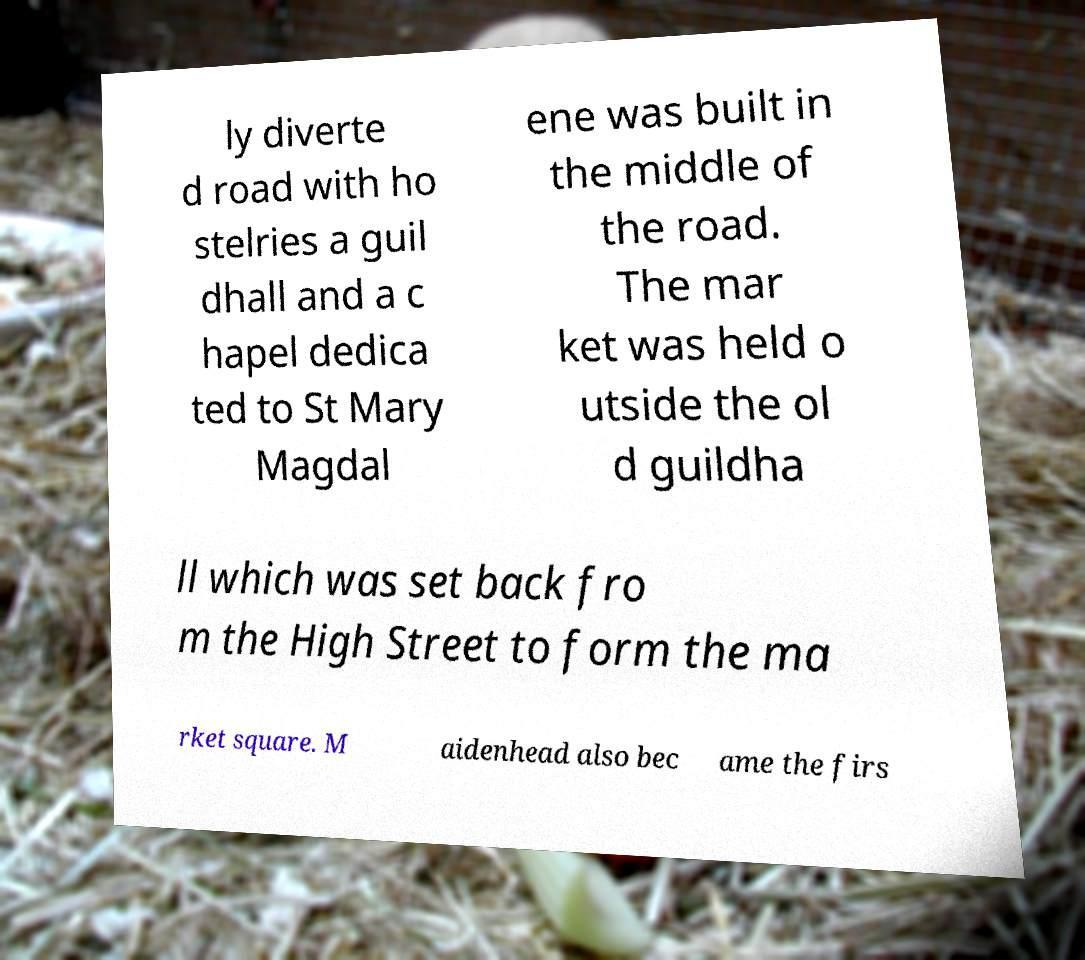Can you accurately transcribe the text from the provided image for me? ly diverte d road with ho stelries a guil dhall and a c hapel dedica ted to St Mary Magdal ene was built in the middle of the road. The mar ket was held o utside the ol d guildha ll which was set back fro m the High Street to form the ma rket square. M aidenhead also bec ame the firs 